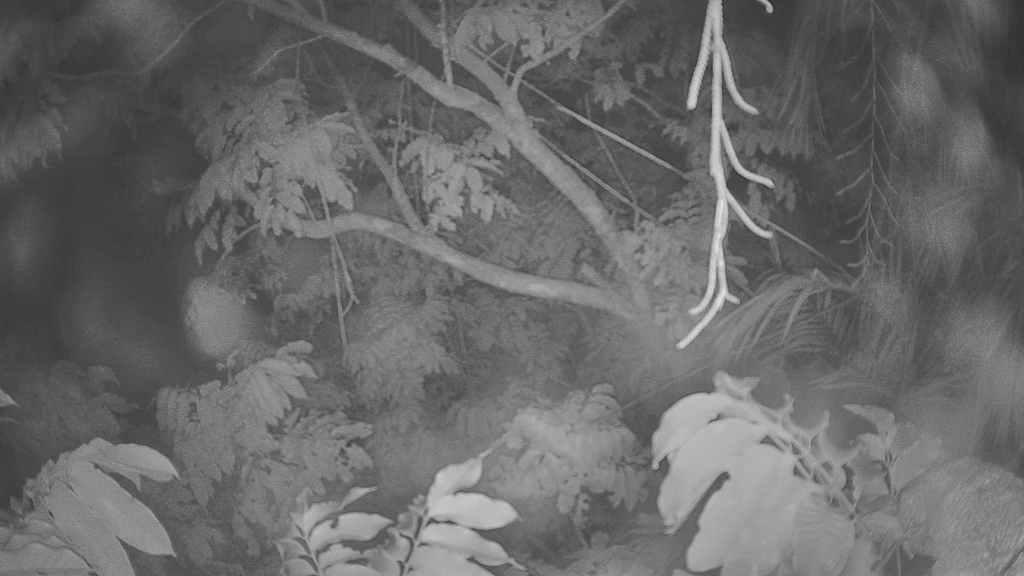What is the primary feature of the image? The primary feature of the image is the presence of many trees. Can you describe the landscape in the image? The landscape in the image is dominated by trees. What might be the setting of the image? The image might depict a forest or a wooded area. What type of motion can be seen in the tub in the image? There is no tub present in the image; it only features many trees. 